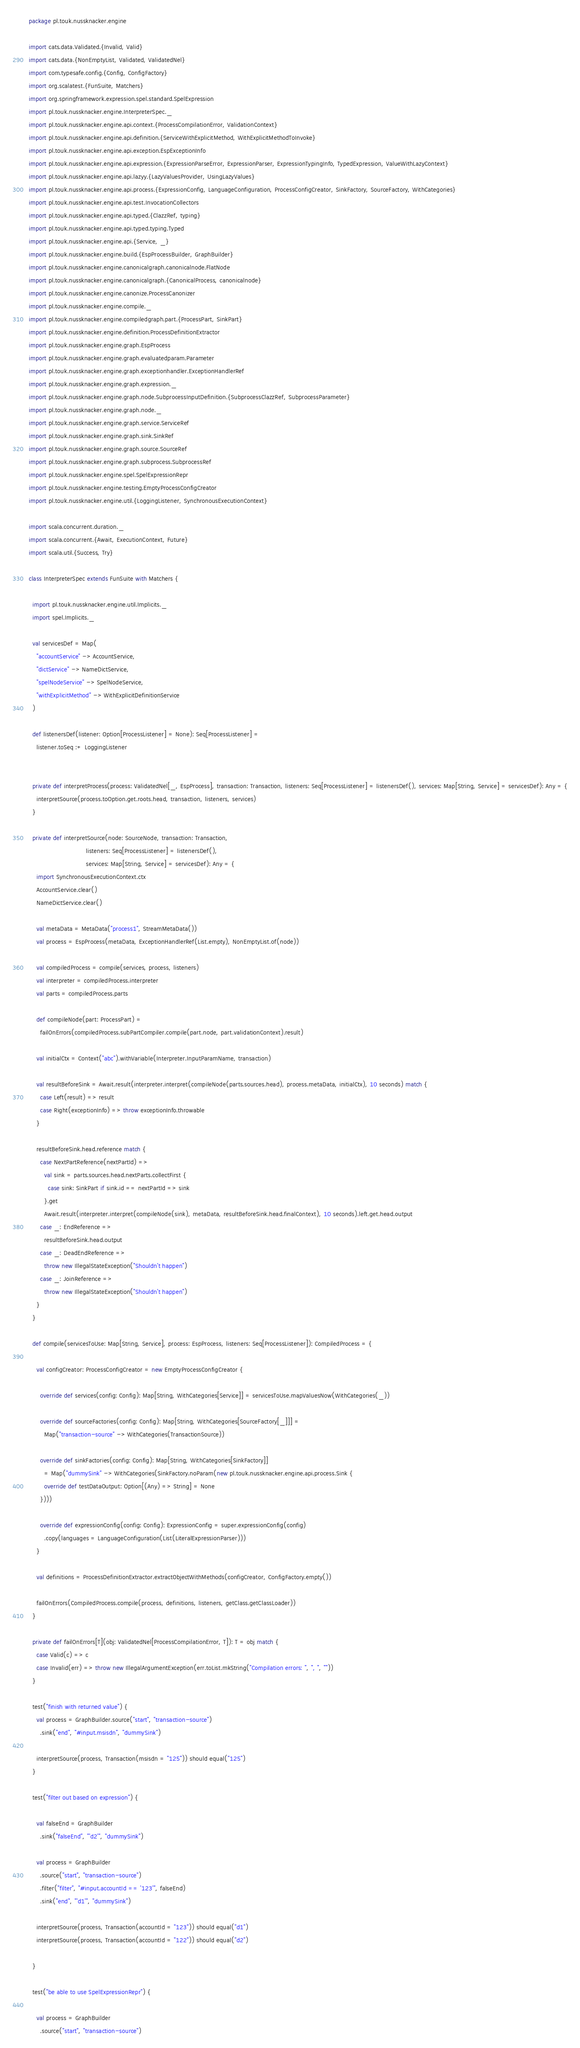Convert code to text. <code><loc_0><loc_0><loc_500><loc_500><_Scala_>package pl.touk.nussknacker.engine

import cats.data.Validated.{Invalid, Valid}
import cats.data.{NonEmptyList, Validated, ValidatedNel}
import com.typesafe.config.{Config, ConfigFactory}
import org.scalatest.{FunSuite, Matchers}
import org.springframework.expression.spel.standard.SpelExpression
import pl.touk.nussknacker.engine.InterpreterSpec._
import pl.touk.nussknacker.engine.api.context.{ProcessCompilationError, ValidationContext}
import pl.touk.nussknacker.engine.api.definition.{ServiceWithExplicitMethod, WithExplicitMethodToInvoke}
import pl.touk.nussknacker.engine.api.exception.EspExceptionInfo
import pl.touk.nussknacker.engine.api.expression.{ExpressionParseError, ExpressionParser, ExpressionTypingInfo, TypedExpression, ValueWithLazyContext}
import pl.touk.nussknacker.engine.api.lazyy.{LazyValuesProvider, UsingLazyValues}
import pl.touk.nussknacker.engine.api.process.{ExpressionConfig, LanguageConfiguration, ProcessConfigCreator, SinkFactory, SourceFactory, WithCategories}
import pl.touk.nussknacker.engine.api.test.InvocationCollectors
import pl.touk.nussknacker.engine.api.typed.{ClazzRef, typing}
import pl.touk.nussknacker.engine.api.typed.typing.Typed
import pl.touk.nussknacker.engine.api.{Service, _}
import pl.touk.nussknacker.engine.build.{EspProcessBuilder, GraphBuilder}
import pl.touk.nussknacker.engine.canonicalgraph.canonicalnode.FlatNode
import pl.touk.nussknacker.engine.canonicalgraph.{CanonicalProcess, canonicalnode}
import pl.touk.nussknacker.engine.canonize.ProcessCanonizer
import pl.touk.nussknacker.engine.compile._
import pl.touk.nussknacker.engine.compiledgraph.part.{ProcessPart, SinkPart}
import pl.touk.nussknacker.engine.definition.ProcessDefinitionExtractor
import pl.touk.nussknacker.engine.graph.EspProcess
import pl.touk.nussknacker.engine.graph.evaluatedparam.Parameter
import pl.touk.nussknacker.engine.graph.exceptionhandler.ExceptionHandlerRef
import pl.touk.nussknacker.engine.graph.expression._
import pl.touk.nussknacker.engine.graph.node.SubprocessInputDefinition.{SubprocessClazzRef, SubprocessParameter}
import pl.touk.nussknacker.engine.graph.node._
import pl.touk.nussknacker.engine.graph.service.ServiceRef
import pl.touk.nussknacker.engine.graph.sink.SinkRef
import pl.touk.nussknacker.engine.graph.source.SourceRef
import pl.touk.nussknacker.engine.graph.subprocess.SubprocessRef
import pl.touk.nussknacker.engine.spel.SpelExpressionRepr
import pl.touk.nussknacker.engine.testing.EmptyProcessConfigCreator
import pl.touk.nussknacker.engine.util.{LoggingListener, SynchronousExecutionContext}

import scala.concurrent.duration._
import scala.concurrent.{Await, ExecutionContext, Future}
import scala.util.{Success, Try}

class InterpreterSpec extends FunSuite with Matchers {

  import pl.touk.nussknacker.engine.util.Implicits._
  import spel.Implicits._

  val servicesDef = Map(
    "accountService" -> AccountService,
    "dictService" -> NameDictService,
    "spelNodeService" -> SpelNodeService,
    "withExplicitMethod" -> WithExplicitDefinitionService
  )

  def listenersDef(listener: Option[ProcessListener] = None): Seq[ProcessListener] =
    listener.toSeq :+ LoggingListener


  private def interpretProcess(process: ValidatedNel[_, EspProcess], transaction: Transaction, listeners: Seq[ProcessListener] = listenersDef(), services: Map[String, Service] = servicesDef): Any = {
    interpretSource(process.toOption.get.roots.head, transaction, listeners, services)
  }

  private def interpretSource(node: SourceNode, transaction: Transaction,
                              listeners: Seq[ProcessListener] = listenersDef(),
                              services: Map[String, Service] = servicesDef): Any = {
    import SynchronousExecutionContext.ctx
    AccountService.clear()
    NameDictService.clear()

    val metaData = MetaData("process1", StreamMetaData())
    val process = EspProcess(metaData, ExceptionHandlerRef(List.empty), NonEmptyList.of(node))

    val compiledProcess = compile(services, process, listeners)
    val interpreter = compiledProcess.interpreter
    val parts = compiledProcess.parts

    def compileNode(part: ProcessPart) =
      failOnErrors(compiledProcess.subPartCompiler.compile(part.node, part.validationContext).result)

    val initialCtx = Context("abc").withVariable(Interpreter.InputParamName, transaction)

    val resultBeforeSink = Await.result(interpreter.interpret(compileNode(parts.sources.head), process.metaData, initialCtx), 10 seconds) match {
      case Left(result) => result
      case Right(exceptionInfo) => throw exceptionInfo.throwable
    }

    resultBeforeSink.head.reference match {
      case NextPartReference(nextPartId) =>
        val sink = parts.sources.head.nextParts.collectFirst {
          case sink: SinkPart if sink.id == nextPartId => sink
        }.get
        Await.result(interpreter.interpret(compileNode(sink), metaData, resultBeforeSink.head.finalContext), 10 seconds).left.get.head.output
      case _: EndReference =>
        resultBeforeSink.head.output
      case _: DeadEndReference =>
        throw new IllegalStateException("Shouldn't happen")
      case _: JoinReference =>
        throw new IllegalStateException("Shouldn't happen")
    }
  }

  def compile(servicesToUse: Map[String, Service], process: EspProcess, listeners: Seq[ProcessListener]): CompiledProcess = {

    val configCreator: ProcessConfigCreator = new EmptyProcessConfigCreator {

      override def services(config: Config): Map[String, WithCategories[Service]] = servicesToUse.mapValuesNow(WithCategories(_))

      override def sourceFactories(config: Config): Map[String, WithCategories[SourceFactory[_]]] =
        Map("transaction-source" -> WithCategories(TransactionSource))

      override def sinkFactories(config: Config): Map[String, WithCategories[SinkFactory]]
        = Map("dummySink" -> WithCategories(SinkFactory.noParam(new pl.touk.nussknacker.engine.api.process.Sink {
        override def testDataOutput: Option[(Any) => String] = None
      })))

      override def expressionConfig(config: Config): ExpressionConfig = super.expressionConfig(config)
        .copy(languages = LanguageConfiguration(List(LiteralExpressionParser)))
    }

    val definitions = ProcessDefinitionExtractor.extractObjectWithMethods(configCreator, ConfigFactory.empty())

    failOnErrors(CompiledProcess.compile(process, definitions, listeners, getClass.getClassLoader))
  }

  private def failOnErrors[T](obj: ValidatedNel[ProcessCompilationError, T]): T = obj match {
    case Valid(c) => c
    case Invalid(err) => throw new IllegalArgumentException(err.toList.mkString("Compilation errors: ", ", ", ""))
  }

  test("finish with returned value") {
    val process = GraphBuilder.source("start", "transaction-source")
      .sink("end", "#input.msisdn", "dummySink")

    interpretSource(process, Transaction(msisdn = "125")) should equal("125")
  }

  test("filter out based on expression") {

    val falseEnd = GraphBuilder
      .sink("falseEnd", "'d2'", "dummySink")

    val process = GraphBuilder
      .source("start", "transaction-source")
      .filter("filter", "#input.accountId == '123'", falseEnd)
      .sink("end", "'d1'", "dummySink")

    interpretSource(process, Transaction(accountId = "123")) should equal("d1")
    interpretSource(process, Transaction(accountId = "122")) should equal("d2")

  }

  test("be able to use SpelExpressionRepr") {

    val process = GraphBuilder
      .source("start", "transaction-source")</code> 